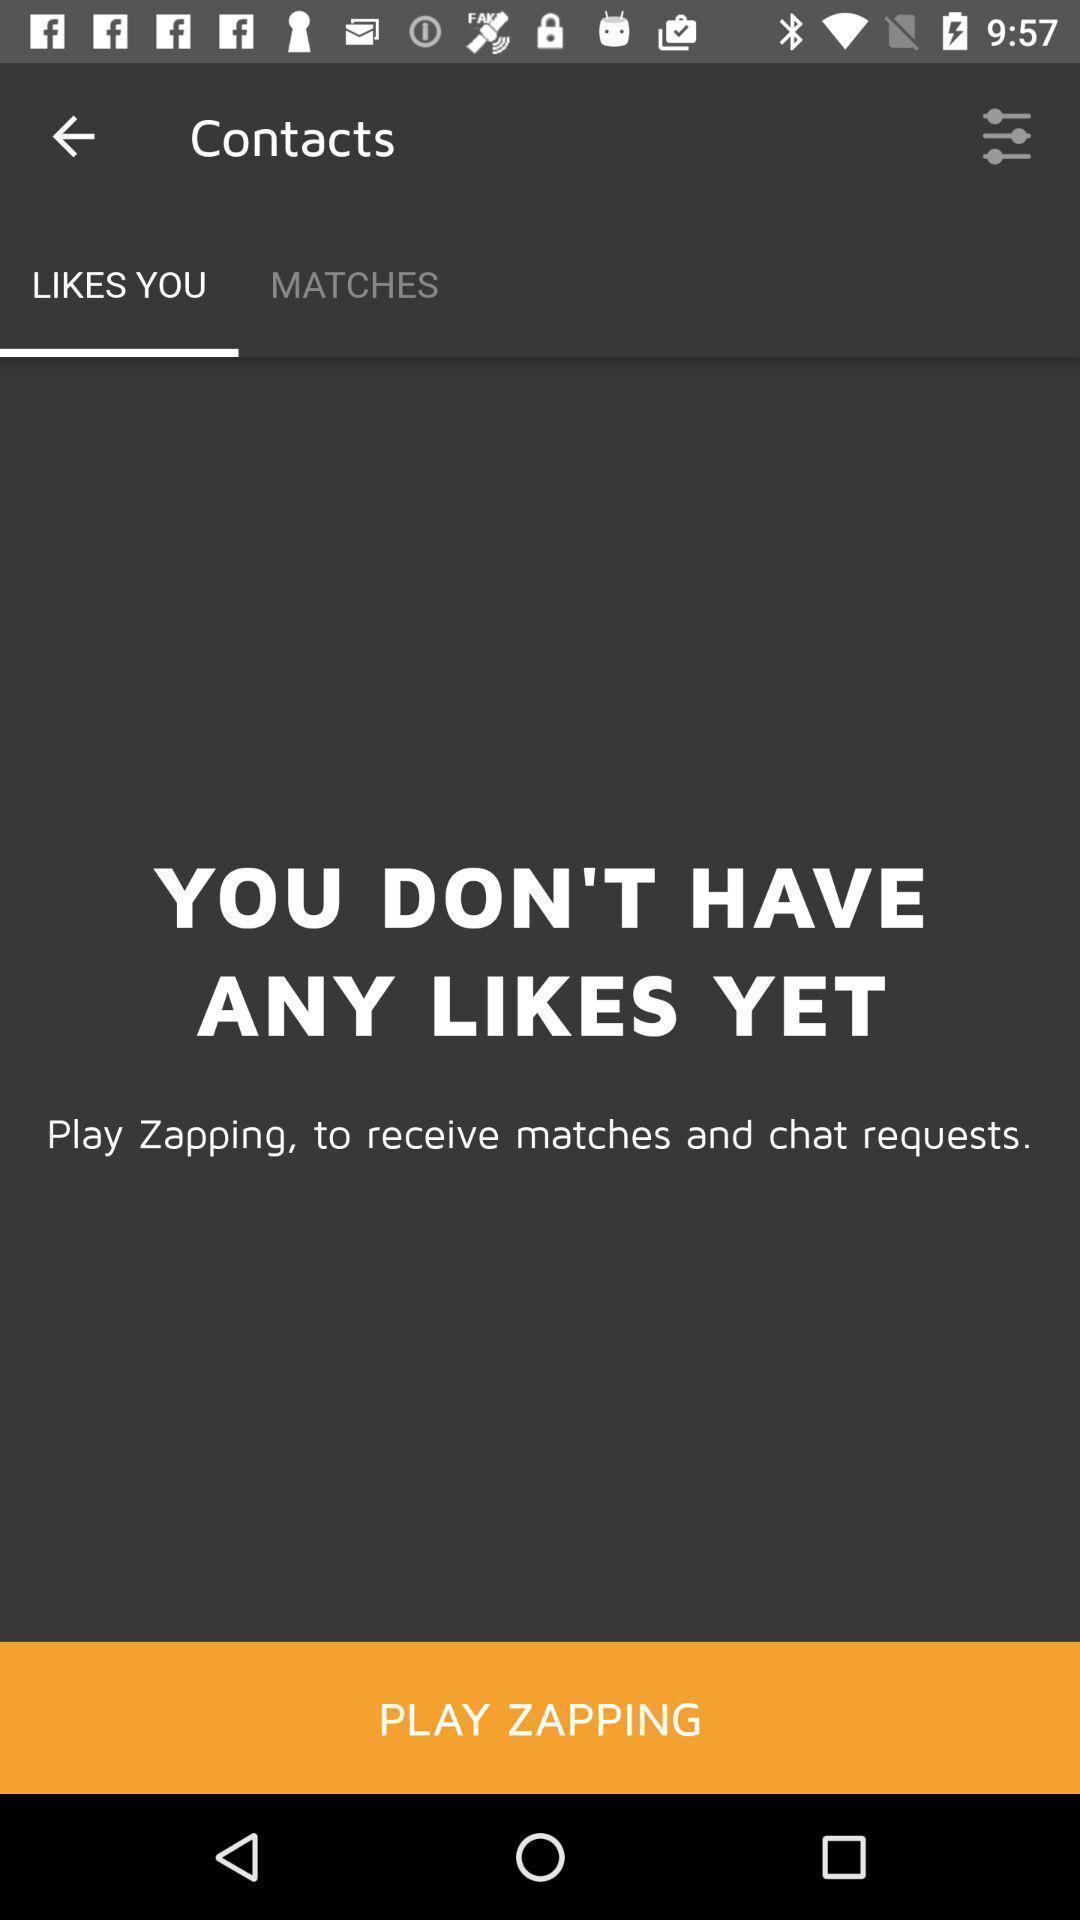Summarize the information in this screenshot. Screen page of a dating app. 